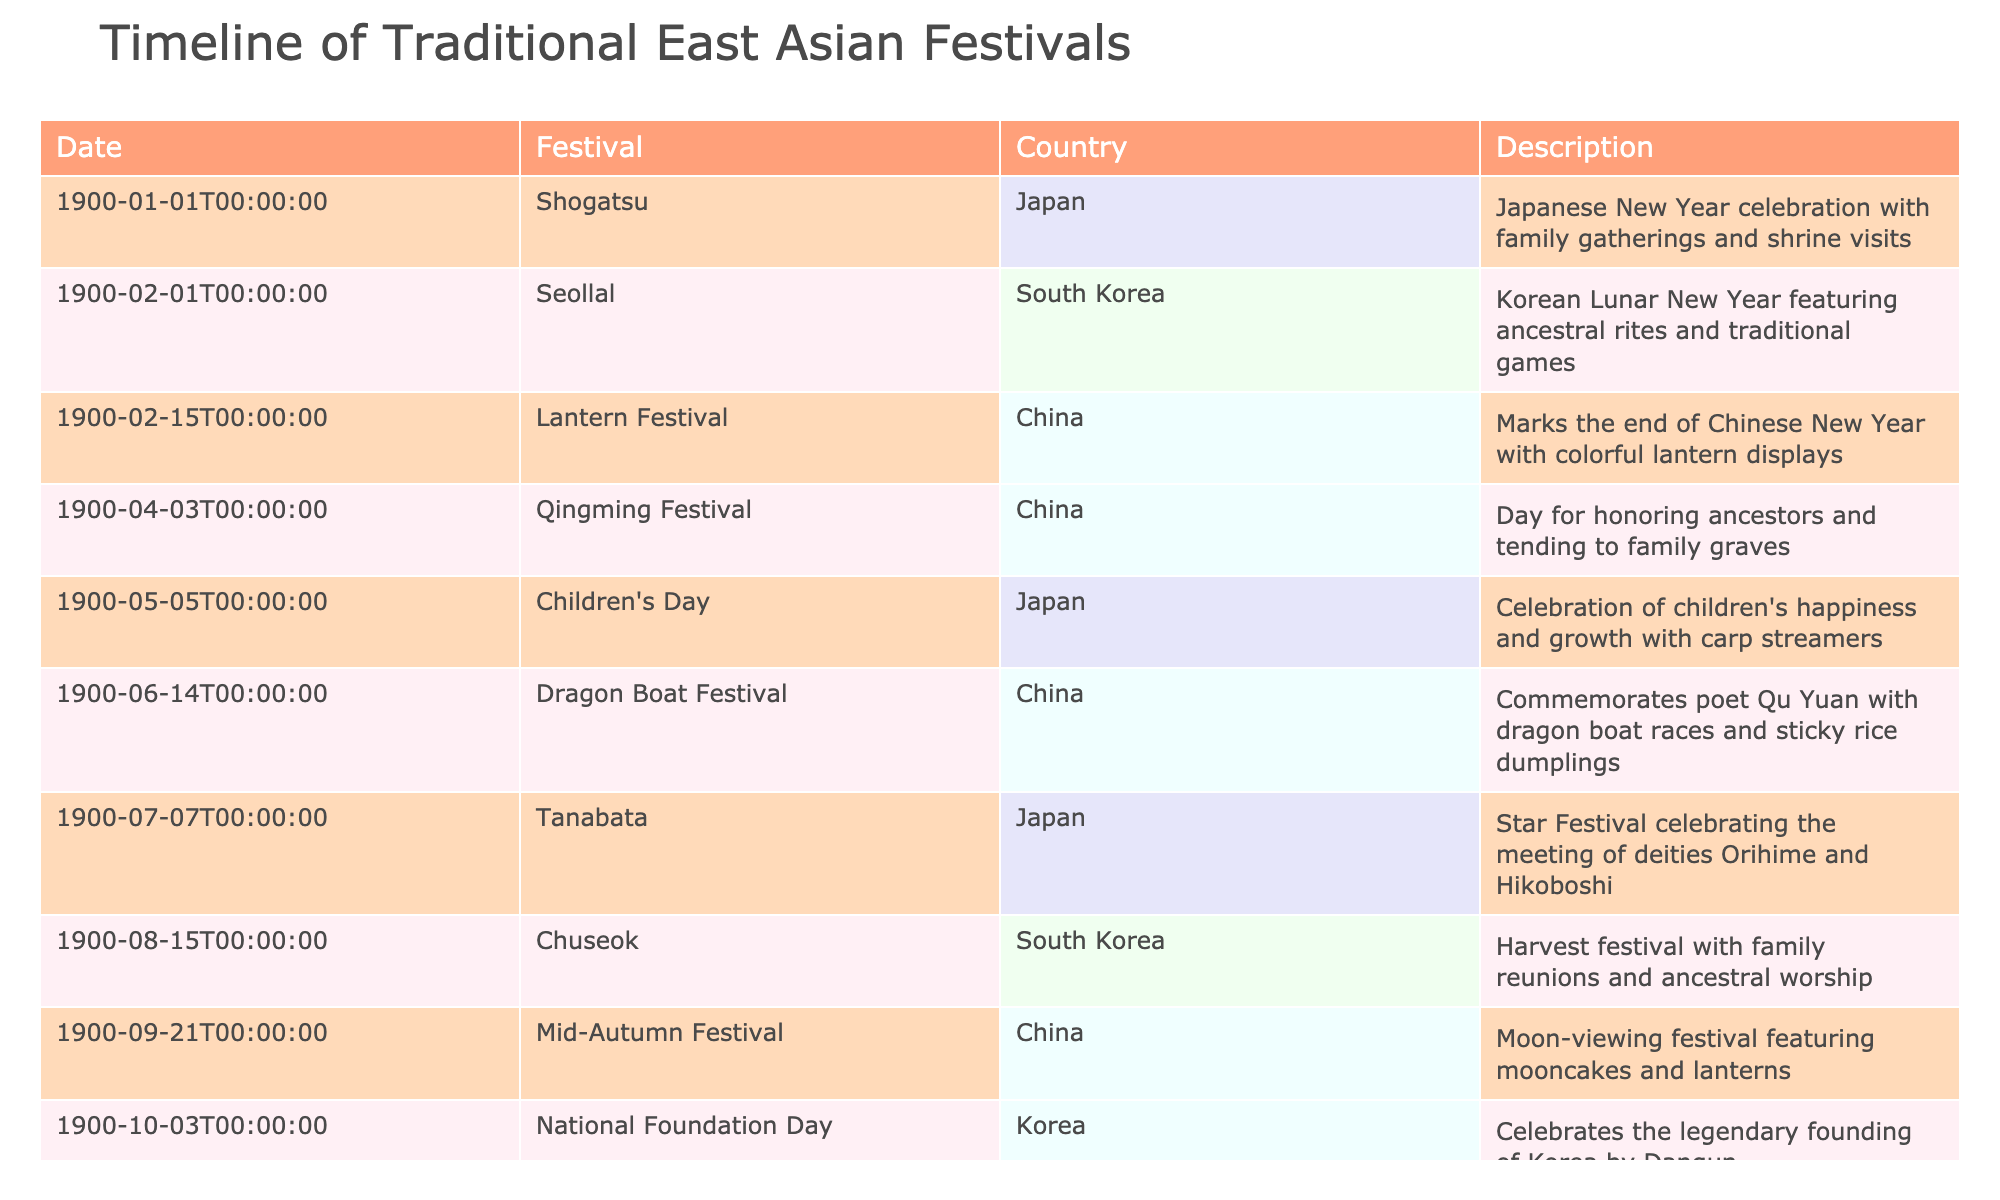What is the festival celebrated on February 1? The table lists "Seollal" as the festival on February 1, which is the Korean Lunar New Year.
Answer: Seollal How many festivals are celebrated in Japan according to the table? By reviewing the table, we see three festivals listed under Japan: Shogatsu in January, Children's Day in May, and Tanabata in July.
Answer: 3 Is the Dragon Boat Festival celebrated in South Korea? The table indicates that the Dragon Boat Festival is associated with China, not South Korea, as it clearly states the country for that festival.
Answer: No Which festival is marked by family reunions and is celebrated in South Korea in August? According to the table, Chuseok, celebrated in August, is noted for family reunions and is specifically listed under South Korea.
Answer: Chuseok What is the difference in months between the Lantern Festival and the Mid-Autumn Festival? The Lantern Festival occurs in February and the Mid-Autumn Festival is in September. Counting the months between these two festivals yields a difference of seven months.
Answer: 7 months What is the significance of the Qingming Festival described in the table? The table states that the Qingming Festival is a day for honoring ancestors and tending to family graves, indicating its cultural significance in remembrance.
Answer: Honoring ancestors Which country has festivals in both February and April listed in the table? Reviewing the table, China has both the Lantern Festival in February and Qingming Festival in April, confirming that it has festivals in those months.
Answer: China How many festivals are celebrated in the same month according to the table? January has one festival (Shogatsu), February has two (Seollal and Lantern Festival), April has one (Qingming Festival), May has one (Children's Day), July has one (Tanabata), August has one (Chuseok), September has one (Mid-Autumn Festival), October has one (National Foundation Day), and December has one (Bodhi Day). Therefore, February is the only month with more than one festival, totaling 2 festivals.
Answer: 2 festivals Are any of the festivals associated with Buddhist traditions? The table indicates that Bodhi Day, celebrated on December 8 and listed as a Buddhist holiday, confirms that there is indeed a festival linked to Buddhist traditions.
Answer: Yes 